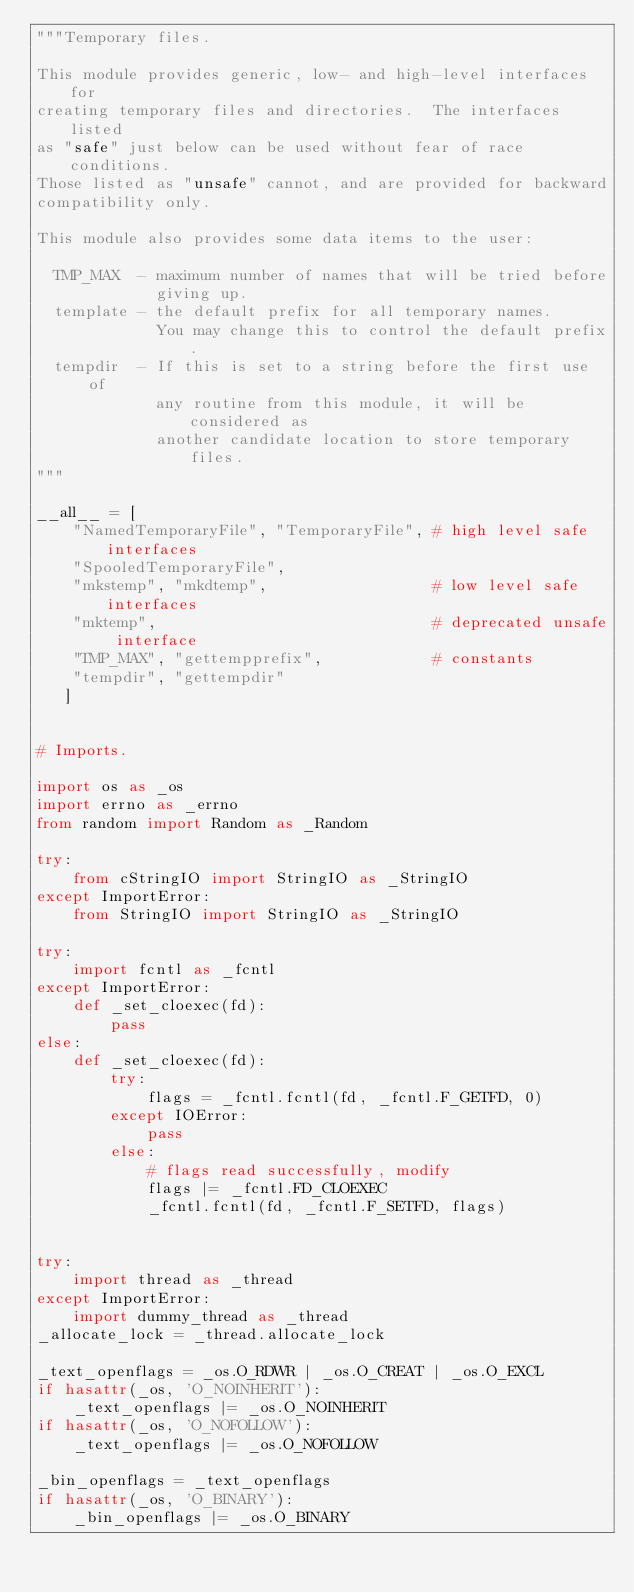<code> <loc_0><loc_0><loc_500><loc_500><_Python_>"""Temporary files.

This module provides generic, low- and high-level interfaces for
creating temporary files and directories.  The interfaces listed
as "safe" just below can be used without fear of race conditions.
Those listed as "unsafe" cannot, and are provided for backward
compatibility only.

This module also provides some data items to the user:

  TMP_MAX  - maximum number of names that will be tried before
             giving up.
  template - the default prefix for all temporary names.
             You may change this to control the default prefix.
  tempdir  - If this is set to a string before the first use of
             any routine from this module, it will be considered as
             another candidate location to store temporary files.
"""

__all__ = [
    "NamedTemporaryFile", "TemporaryFile", # high level safe interfaces
    "SpooledTemporaryFile",
    "mkstemp", "mkdtemp",                  # low level safe interfaces
    "mktemp",                              # deprecated unsafe interface
    "TMP_MAX", "gettempprefix",            # constants
    "tempdir", "gettempdir"
   ]


# Imports.

import os as _os
import errno as _errno
from random import Random as _Random

try:
    from cStringIO import StringIO as _StringIO
except ImportError:
    from StringIO import StringIO as _StringIO

try:
    import fcntl as _fcntl
except ImportError:
    def _set_cloexec(fd):
        pass
else:
    def _set_cloexec(fd):
        try:
            flags = _fcntl.fcntl(fd, _fcntl.F_GETFD, 0)
        except IOError:
            pass
        else:
            # flags read successfully, modify
            flags |= _fcntl.FD_CLOEXEC
            _fcntl.fcntl(fd, _fcntl.F_SETFD, flags)


try:
    import thread as _thread
except ImportError:
    import dummy_thread as _thread
_allocate_lock = _thread.allocate_lock

_text_openflags = _os.O_RDWR | _os.O_CREAT | _os.O_EXCL
if hasattr(_os, 'O_NOINHERIT'):
    _text_openflags |= _os.O_NOINHERIT
if hasattr(_os, 'O_NOFOLLOW'):
    _text_openflags |= _os.O_NOFOLLOW

_bin_openflags = _text_openflags
if hasattr(_os, 'O_BINARY'):
    _bin_openflags |= _os.O_BINARY
</code> 